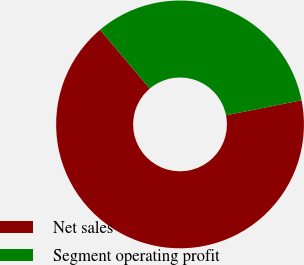<chart> <loc_0><loc_0><loc_500><loc_500><pie_chart><fcel>Net sales<fcel>Segment operating profit<nl><fcel>66.96%<fcel>33.04%<nl></chart> 